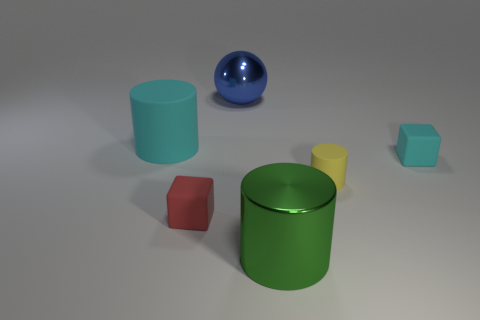Add 2 big balls. How many objects exist? 8 Subtract all spheres. How many objects are left? 5 Add 1 tiny rubber blocks. How many tiny rubber blocks exist? 3 Subtract 0 blue cylinders. How many objects are left? 6 Subtract all large cyan things. Subtract all small yellow matte things. How many objects are left? 4 Add 3 tiny things. How many tiny things are left? 6 